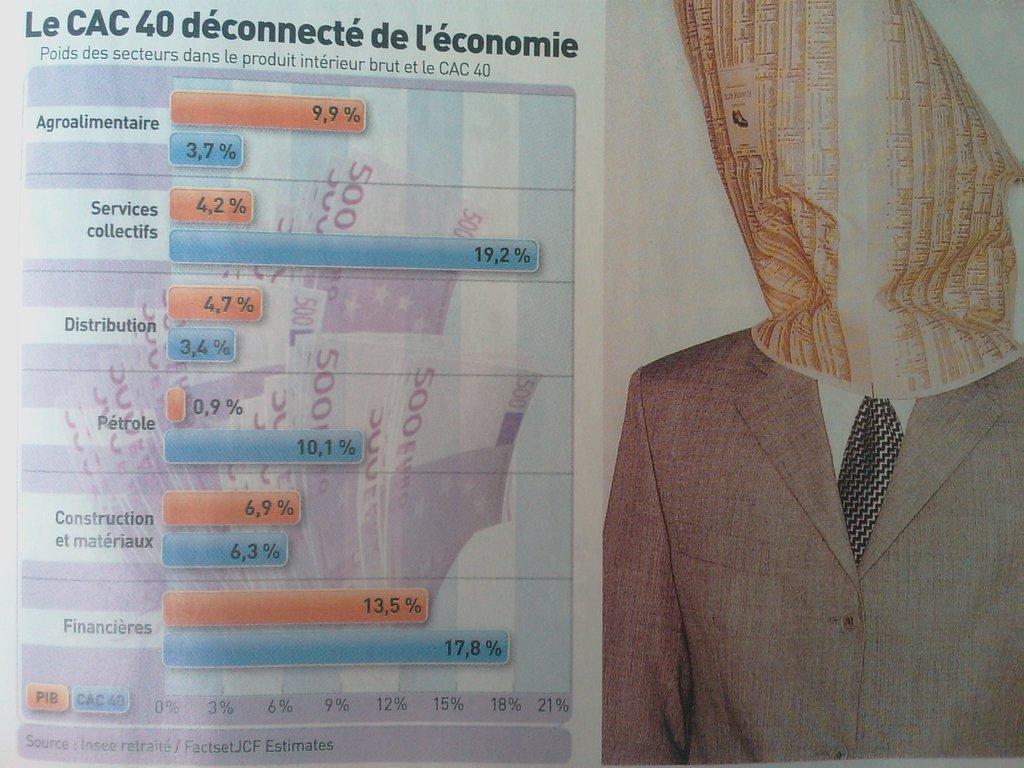Could you give a brief overview of what you see in this image? This is a poster and in this poster we can see a blazer, tie, paper, symbols and some text. 